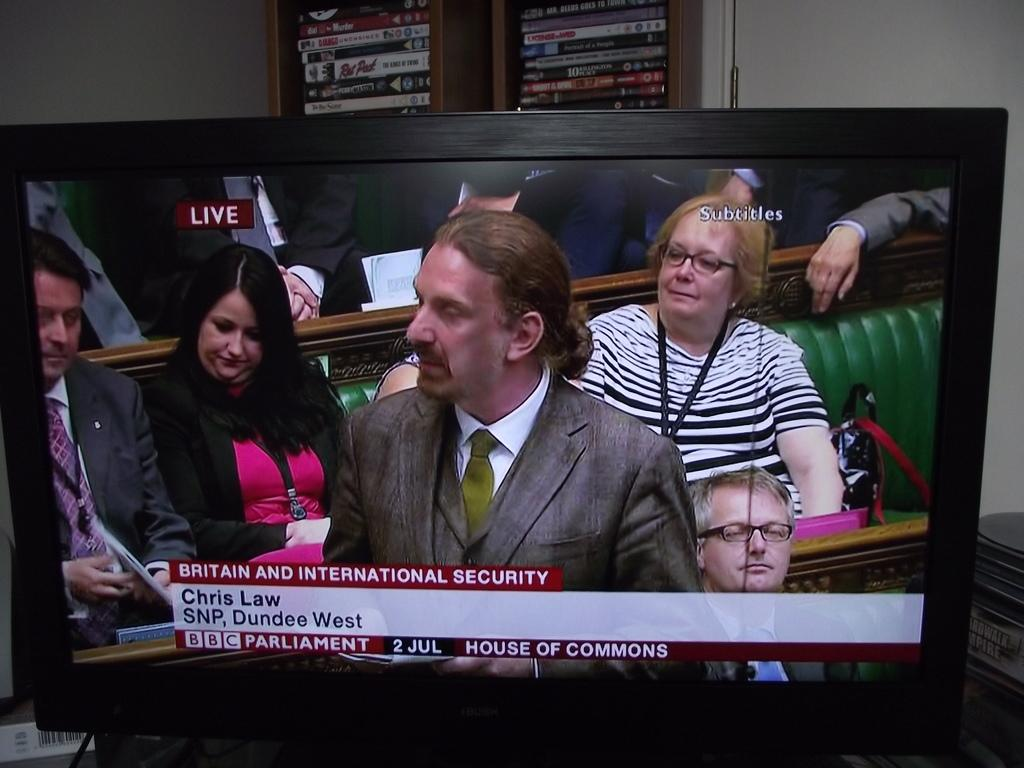Provide a one-sentence caption for the provided image. On a tv, a man named Chris Law speaks in the house of commons. 